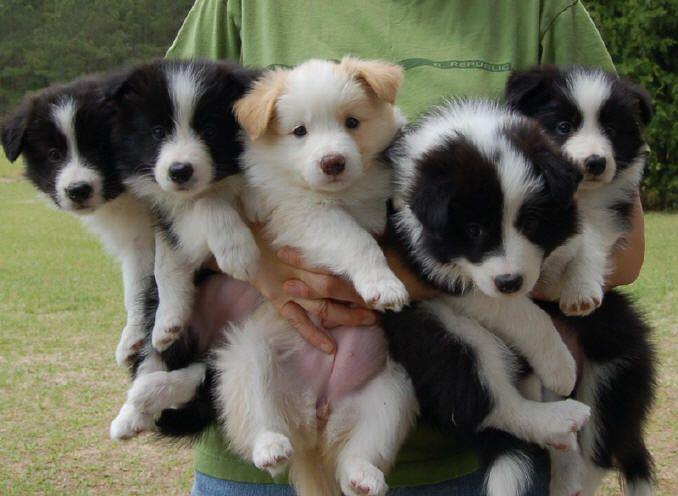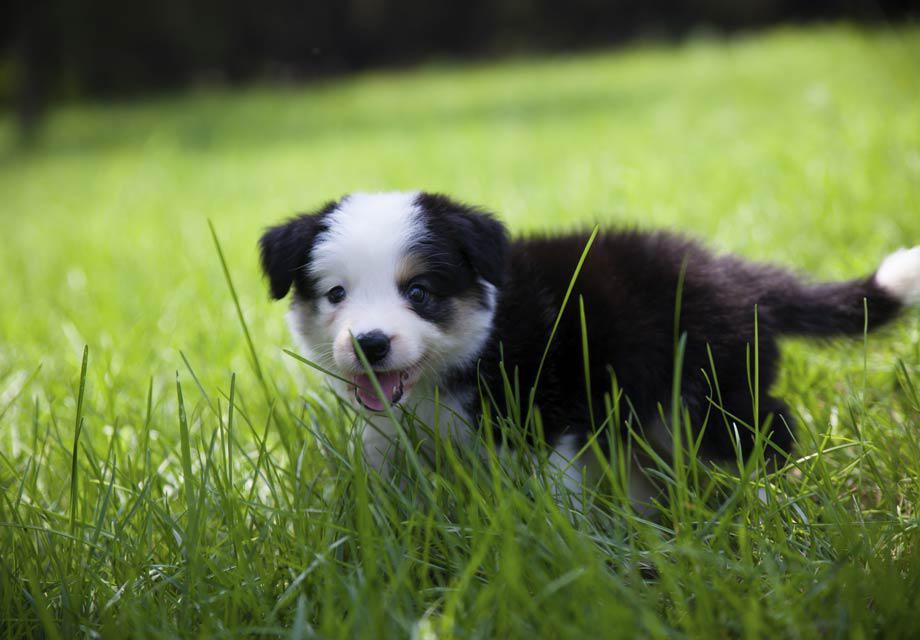The first image is the image on the left, the second image is the image on the right. Analyze the images presented: Is the assertion "The dog on the left has a leash around its neck." valid? Answer yes or no. No. The first image is the image on the left, the second image is the image on the right. Examine the images to the left and right. Is the description "There are two dogs in total." accurate? Answer yes or no. No. 